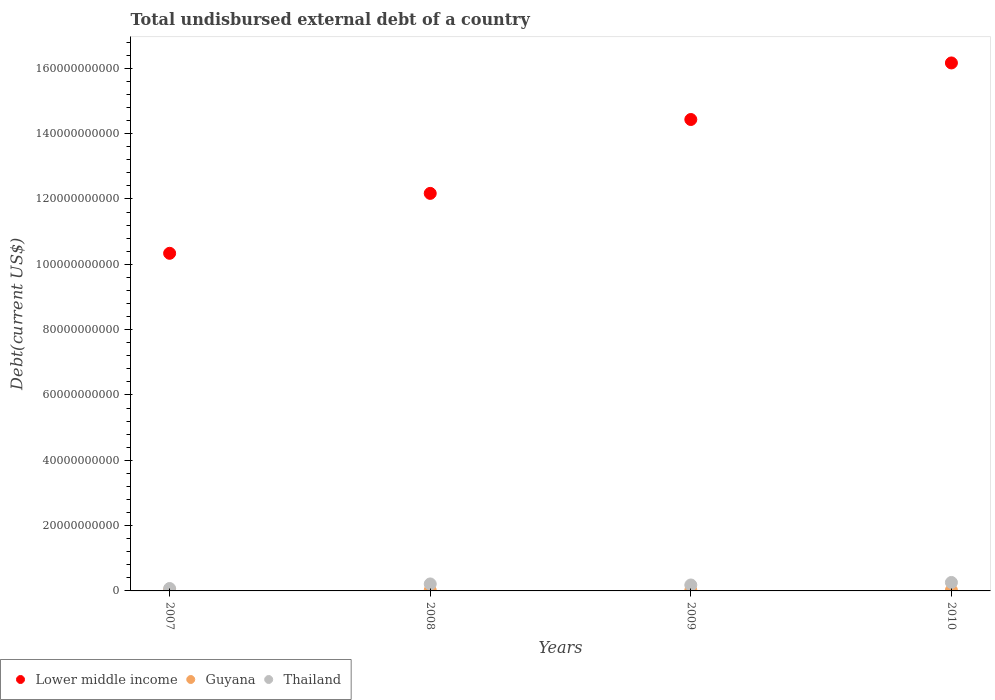What is the total undisbursed external debt in Guyana in 2008?
Ensure brevity in your answer.  2.27e+08. Across all years, what is the maximum total undisbursed external debt in Thailand?
Give a very brief answer. 2.59e+09. Across all years, what is the minimum total undisbursed external debt in Guyana?
Ensure brevity in your answer.  1.93e+08. In which year was the total undisbursed external debt in Thailand maximum?
Ensure brevity in your answer.  2010. In which year was the total undisbursed external debt in Lower middle income minimum?
Your response must be concise. 2007. What is the total total undisbursed external debt in Guyana in the graph?
Provide a short and direct response. 8.89e+08. What is the difference between the total undisbursed external debt in Lower middle income in 2007 and that in 2008?
Offer a very short reply. -1.83e+1. What is the difference between the total undisbursed external debt in Lower middle income in 2007 and the total undisbursed external debt in Guyana in 2009?
Give a very brief answer. 1.03e+11. What is the average total undisbursed external debt in Thailand per year?
Give a very brief answer. 1.82e+09. In the year 2008, what is the difference between the total undisbursed external debt in Thailand and total undisbursed external debt in Lower middle income?
Offer a terse response. -1.20e+11. In how many years, is the total undisbursed external debt in Lower middle income greater than 60000000000 US$?
Provide a succinct answer. 4. What is the ratio of the total undisbursed external debt in Guyana in 2007 to that in 2009?
Keep it short and to the point. 1.27. Is the total undisbursed external debt in Thailand in 2008 less than that in 2010?
Offer a terse response. Yes. Is the difference between the total undisbursed external debt in Thailand in 2007 and 2008 greater than the difference between the total undisbursed external debt in Lower middle income in 2007 and 2008?
Offer a very short reply. Yes. What is the difference between the highest and the second highest total undisbursed external debt in Guyana?
Your answer should be compact. 1.87e+07. What is the difference between the highest and the lowest total undisbursed external debt in Guyana?
Provide a succinct answer. 5.26e+07. Is it the case that in every year, the sum of the total undisbursed external debt in Thailand and total undisbursed external debt in Lower middle income  is greater than the total undisbursed external debt in Guyana?
Offer a terse response. Yes. Is the total undisbursed external debt in Thailand strictly greater than the total undisbursed external debt in Lower middle income over the years?
Give a very brief answer. No. Is the total undisbursed external debt in Lower middle income strictly less than the total undisbursed external debt in Thailand over the years?
Give a very brief answer. No. How many years are there in the graph?
Provide a short and direct response. 4. Are the values on the major ticks of Y-axis written in scientific E-notation?
Keep it short and to the point. No. Does the graph contain grids?
Give a very brief answer. No. What is the title of the graph?
Provide a succinct answer. Total undisbursed external debt of a country. Does "Arab World" appear as one of the legend labels in the graph?
Provide a succinct answer. No. What is the label or title of the X-axis?
Your answer should be compact. Years. What is the label or title of the Y-axis?
Ensure brevity in your answer.  Debt(current US$). What is the Debt(current US$) in Lower middle income in 2007?
Offer a very short reply. 1.03e+11. What is the Debt(current US$) in Guyana in 2007?
Offer a terse response. 2.45e+08. What is the Debt(current US$) of Thailand in 2007?
Provide a short and direct response. 7.42e+08. What is the Debt(current US$) of Lower middle income in 2008?
Give a very brief answer. 1.22e+11. What is the Debt(current US$) in Guyana in 2008?
Provide a short and direct response. 2.27e+08. What is the Debt(current US$) of Thailand in 2008?
Offer a terse response. 2.14e+09. What is the Debt(current US$) in Lower middle income in 2009?
Offer a very short reply. 1.44e+11. What is the Debt(current US$) in Guyana in 2009?
Ensure brevity in your answer.  1.93e+08. What is the Debt(current US$) of Thailand in 2009?
Provide a short and direct response. 1.82e+09. What is the Debt(current US$) in Lower middle income in 2010?
Provide a succinct answer. 1.62e+11. What is the Debt(current US$) of Guyana in 2010?
Provide a short and direct response. 2.25e+08. What is the Debt(current US$) in Thailand in 2010?
Ensure brevity in your answer.  2.59e+09. Across all years, what is the maximum Debt(current US$) in Lower middle income?
Offer a terse response. 1.62e+11. Across all years, what is the maximum Debt(current US$) of Guyana?
Give a very brief answer. 2.45e+08. Across all years, what is the maximum Debt(current US$) of Thailand?
Your answer should be very brief. 2.59e+09. Across all years, what is the minimum Debt(current US$) of Lower middle income?
Provide a short and direct response. 1.03e+11. Across all years, what is the minimum Debt(current US$) in Guyana?
Your response must be concise. 1.93e+08. Across all years, what is the minimum Debt(current US$) in Thailand?
Make the answer very short. 7.42e+08. What is the total Debt(current US$) of Lower middle income in the graph?
Ensure brevity in your answer.  5.31e+11. What is the total Debt(current US$) in Guyana in the graph?
Provide a succinct answer. 8.89e+08. What is the total Debt(current US$) in Thailand in the graph?
Make the answer very short. 7.29e+09. What is the difference between the Debt(current US$) of Lower middle income in 2007 and that in 2008?
Your response must be concise. -1.83e+1. What is the difference between the Debt(current US$) in Guyana in 2007 and that in 2008?
Your response must be concise. 1.87e+07. What is the difference between the Debt(current US$) of Thailand in 2007 and that in 2008?
Ensure brevity in your answer.  -1.39e+09. What is the difference between the Debt(current US$) in Lower middle income in 2007 and that in 2009?
Ensure brevity in your answer.  -4.10e+1. What is the difference between the Debt(current US$) of Guyana in 2007 and that in 2009?
Give a very brief answer. 5.26e+07. What is the difference between the Debt(current US$) of Thailand in 2007 and that in 2009?
Make the answer very short. -1.08e+09. What is the difference between the Debt(current US$) of Lower middle income in 2007 and that in 2010?
Offer a very short reply. -5.83e+1. What is the difference between the Debt(current US$) of Guyana in 2007 and that in 2010?
Keep it short and to the point. 2.07e+07. What is the difference between the Debt(current US$) in Thailand in 2007 and that in 2010?
Make the answer very short. -1.85e+09. What is the difference between the Debt(current US$) in Lower middle income in 2008 and that in 2009?
Provide a short and direct response. -2.26e+1. What is the difference between the Debt(current US$) of Guyana in 2008 and that in 2009?
Give a very brief answer. 3.39e+07. What is the difference between the Debt(current US$) of Thailand in 2008 and that in 2009?
Offer a terse response. 3.17e+08. What is the difference between the Debt(current US$) of Lower middle income in 2008 and that in 2010?
Your answer should be very brief. -3.99e+1. What is the difference between the Debt(current US$) in Guyana in 2008 and that in 2010?
Make the answer very short. 2.02e+06. What is the difference between the Debt(current US$) in Thailand in 2008 and that in 2010?
Your answer should be compact. -4.56e+08. What is the difference between the Debt(current US$) in Lower middle income in 2009 and that in 2010?
Your response must be concise. -1.73e+1. What is the difference between the Debt(current US$) of Guyana in 2009 and that in 2010?
Give a very brief answer. -3.19e+07. What is the difference between the Debt(current US$) in Thailand in 2009 and that in 2010?
Provide a short and direct response. -7.73e+08. What is the difference between the Debt(current US$) in Lower middle income in 2007 and the Debt(current US$) in Guyana in 2008?
Offer a terse response. 1.03e+11. What is the difference between the Debt(current US$) in Lower middle income in 2007 and the Debt(current US$) in Thailand in 2008?
Your answer should be compact. 1.01e+11. What is the difference between the Debt(current US$) in Guyana in 2007 and the Debt(current US$) in Thailand in 2008?
Give a very brief answer. -1.89e+09. What is the difference between the Debt(current US$) of Lower middle income in 2007 and the Debt(current US$) of Guyana in 2009?
Your answer should be compact. 1.03e+11. What is the difference between the Debt(current US$) of Lower middle income in 2007 and the Debt(current US$) of Thailand in 2009?
Your answer should be compact. 1.02e+11. What is the difference between the Debt(current US$) in Guyana in 2007 and the Debt(current US$) in Thailand in 2009?
Your response must be concise. -1.57e+09. What is the difference between the Debt(current US$) of Lower middle income in 2007 and the Debt(current US$) of Guyana in 2010?
Your answer should be very brief. 1.03e+11. What is the difference between the Debt(current US$) of Lower middle income in 2007 and the Debt(current US$) of Thailand in 2010?
Keep it short and to the point. 1.01e+11. What is the difference between the Debt(current US$) of Guyana in 2007 and the Debt(current US$) of Thailand in 2010?
Give a very brief answer. -2.35e+09. What is the difference between the Debt(current US$) of Lower middle income in 2008 and the Debt(current US$) of Guyana in 2009?
Keep it short and to the point. 1.22e+11. What is the difference between the Debt(current US$) in Lower middle income in 2008 and the Debt(current US$) in Thailand in 2009?
Make the answer very short. 1.20e+11. What is the difference between the Debt(current US$) in Guyana in 2008 and the Debt(current US$) in Thailand in 2009?
Offer a very short reply. -1.59e+09. What is the difference between the Debt(current US$) in Lower middle income in 2008 and the Debt(current US$) in Guyana in 2010?
Your response must be concise. 1.21e+11. What is the difference between the Debt(current US$) of Lower middle income in 2008 and the Debt(current US$) of Thailand in 2010?
Your answer should be compact. 1.19e+11. What is the difference between the Debt(current US$) of Guyana in 2008 and the Debt(current US$) of Thailand in 2010?
Make the answer very short. -2.37e+09. What is the difference between the Debt(current US$) in Lower middle income in 2009 and the Debt(current US$) in Guyana in 2010?
Make the answer very short. 1.44e+11. What is the difference between the Debt(current US$) of Lower middle income in 2009 and the Debt(current US$) of Thailand in 2010?
Provide a short and direct response. 1.42e+11. What is the difference between the Debt(current US$) of Guyana in 2009 and the Debt(current US$) of Thailand in 2010?
Make the answer very short. -2.40e+09. What is the average Debt(current US$) in Lower middle income per year?
Ensure brevity in your answer.  1.33e+11. What is the average Debt(current US$) of Guyana per year?
Provide a short and direct response. 2.22e+08. What is the average Debt(current US$) in Thailand per year?
Provide a short and direct response. 1.82e+09. In the year 2007, what is the difference between the Debt(current US$) in Lower middle income and Debt(current US$) in Guyana?
Give a very brief answer. 1.03e+11. In the year 2007, what is the difference between the Debt(current US$) in Lower middle income and Debt(current US$) in Thailand?
Keep it short and to the point. 1.03e+11. In the year 2007, what is the difference between the Debt(current US$) in Guyana and Debt(current US$) in Thailand?
Make the answer very short. -4.97e+08. In the year 2008, what is the difference between the Debt(current US$) in Lower middle income and Debt(current US$) in Guyana?
Your answer should be very brief. 1.21e+11. In the year 2008, what is the difference between the Debt(current US$) of Lower middle income and Debt(current US$) of Thailand?
Your answer should be compact. 1.20e+11. In the year 2008, what is the difference between the Debt(current US$) in Guyana and Debt(current US$) in Thailand?
Your response must be concise. -1.91e+09. In the year 2009, what is the difference between the Debt(current US$) of Lower middle income and Debt(current US$) of Guyana?
Keep it short and to the point. 1.44e+11. In the year 2009, what is the difference between the Debt(current US$) of Lower middle income and Debt(current US$) of Thailand?
Your response must be concise. 1.43e+11. In the year 2009, what is the difference between the Debt(current US$) in Guyana and Debt(current US$) in Thailand?
Your response must be concise. -1.63e+09. In the year 2010, what is the difference between the Debt(current US$) in Lower middle income and Debt(current US$) in Guyana?
Offer a very short reply. 1.61e+11. In the year 2010, what is the difference between the Debt(current US$) in Lower middle income and Debt(current US$) in Thailand?
Keep it short and to the point. 1.59e+11. In the year 2010, what is the difference between the Debt(current US$) in Guyana and Debt(current US$) in Thailand?
Give a very brief answer. -2.37e+09. What is the ratio of the Debt(current US$) in Lower middle income in 2007 to that in 2008?
Keep it short and to the point. 0.85. What is the ratio of the Debt(current US$) of Guyana in 2007 to that in 2008?
Give a very brief answer. 1.08. What is the ratio of the Debt(current US$) of Thailand in 2007 to that in 2008?
Offer a very short reply. 0.35. What is the ratio of the Debt(current US$) in Lower middle income in 2007 to that in 2009?
Your response must be concise. 0.72. What is the ratio of the Debt(current US$) of Guyana in 2007 to that in 2009?
Provide a succinct answer. 1.27. What is the ratio of the Debt(current US$) in Thailand in 2007 to that in 2009?
Ensure brevity in your answer.  0.41. What is the ratio of the Debt(current US$) in Lower middle income in 2007 to that in 2010?
Offer a very short reply. 0.64. What is the ratio of the Debt(current US$) of Guyana in 2007 to that in 2010?
Your answer should be compact. 1.09. What is the ratio of the Debt(current US$) in Thailand in 2007 to that in 2010?
Provide a succinct answer. 0.29. What is the ratio of the Debt(current US$) in Lower middle income in 2008 to that in 2009?
Ensure brevity in your answer.  0.84. What is the ratio of the Debt(current US$) in Guyana in 2008 to that in 2009?
Your answer should be very brief. 1.18. What is the ratio of the Debt(current US$) in Thailand in 2008 to that in 2009?
Make the answer very short. 1.17. What is the ratio of the Debt(current US$) in Lower middle income in 2008 to that in 2010?
Your response must be concise. 0.75. What is the ratio of the Debt(current US$) in Guyana in 2008 to that in 2010?
Keep it short and to the point. 1.01. What is the ratio of the Debt(current US$) in Thailand in 2008 to that in 2010?
Your answer should be compact. 0.82. What is the ratio of the Debt(current US$) in Lower middle income in 2009 to that in 2010?
Offer a very short reply. 0.89. What is the ratio of the Debt(current US$) of Guyana in 2009 to that in 2010?
Offer a very short reply. 0.86. What is the ratio of the Debt(current US$) in Thailand in 2009 to that in 2010?
Ensure brevity in your answer.  0.7. What is the difference between the highest and the second highest Debt(current US$) of Lower middle income?
Offer a very short reply. 1.73e+1. What is the difference between the highest and the second highest Debt(current US$) of Guyana?
Make the answer very short. 1.87e+07. What is the difference between the highest and the second highest Debt(current US$) of Thailand?
Offer a terse response. 4.56e+08. What is the difference between the highest and the lowest Debt(current US$) in Lower middle income?
Offer a terse response. 5.83e+1. What is the difference between the highest and the lowest Debt(current US$) of Guyana?
Your answer should be compact. 5.26e+07. What is the difference between the highest and the lowest Debt(current US$) in Thailand?
Ensure brevity in your answer.  1.85e+09. 